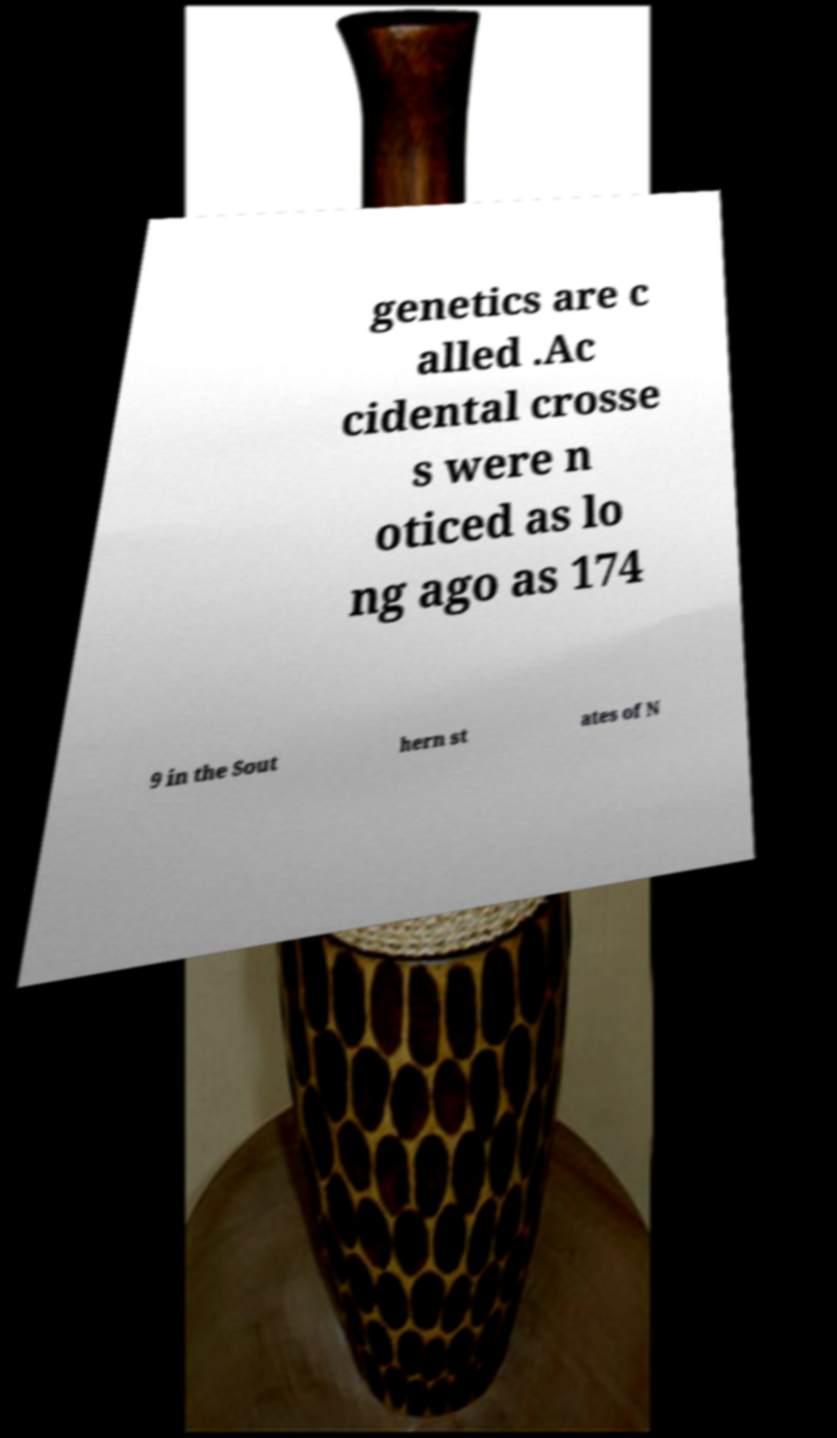I need the written content from this picture converted into text. Can you do that? genetics are c alled .Ac cidental crosse s were n oticed as lo ng ago as 174 9 in the Sout hern st ates of N 